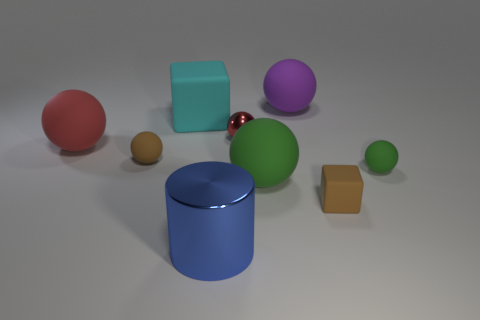Can you describe the texture and appearance of the materials in this scene? Certainly! The image showcases a variety of objects with different textures and sheens. The sphere and cylinder on the left have a smooth and glossy finish, reflecting light and showcasing shiny surfaces. The cube and the spherical object to the right appear to have a matte finish with diffused reflections, indicating a non-glossy texture. The brown ball is tiny and has a less reflective surface compared to the red sphere, suggesting a possibly rougher texture. 